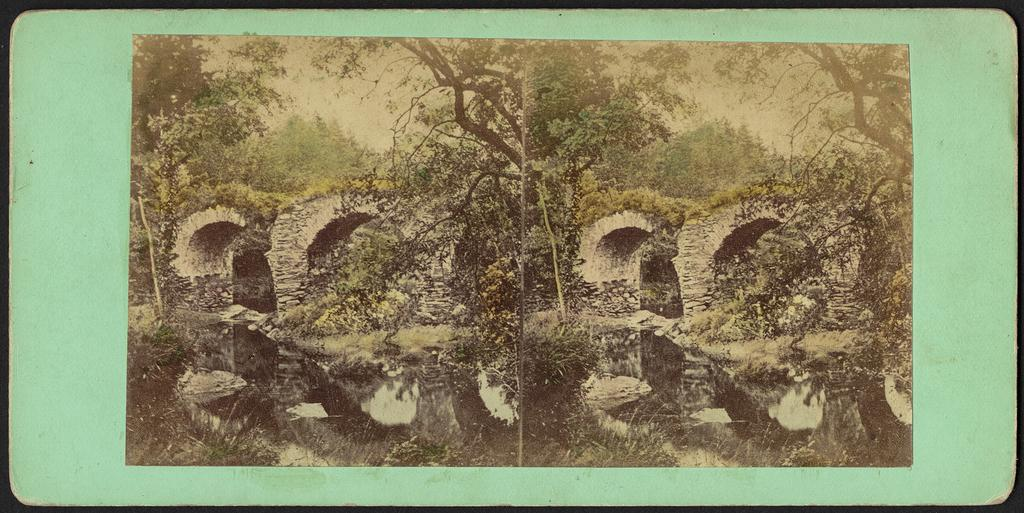What type of artwork is the image? The image is a collage. What architectural feature can be seen in the image? There are arches in the image. What type of natural elements are present in the image? There are trees, rocks, and water visible in the image. What type of vegetation is present at the bottom of the image? There are plants at the bottom of the image. What part of the natural environment is visible at the top of the image? The sky is visible at the top of the image. Who is the expert working on the apparatus in the image? There is no expert or apparatus present in the image; it is a collage featuring arches, trees, rocks, water, plants, and the sky. 